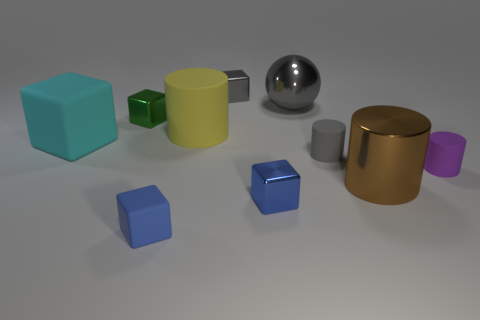There is a tiny object that is the same color as the small rubber cube; what is its material?
Your response must be concise. Metal. There is a brown cylinder that is on the right side of the big matte object that is to the left of the yellow object; are there any tiny objects that are to the right of it?
Ensure brevity in your answer.  Yes. How many objects are either tiny blocks behind the metallic ball or metallic objects that are on the right side of the tiny matte block?
Give a very brief answer. 4. Is the material of the cylinder behind the big cyan thing the same as the tiny purple thing?
Keep it short and to the point. Yes. There is a big thing that is to the right of the big matte cylinder and in front of the yellow matte object; what is it made of?
Offer a very short reply. Metal. What is the color of the matte thing that is on the left side of the matte cube that is in front of the purple matte thing?
Provide a succinct answer. Cyan. There is a brown object that is the same shape as the big yellow object; what material is it?
Give a very brief answer. Metal. The big matte thing that is on the right side of the large matte thing in front of the big cylinder behind the small purple matte cylinder is what color?
Your answer should be very brief. Yellow. What number of objects are tiny purple rubber things or green shiny spheres?
Offer a very short reply. 1. How many big gray things have the same shape as the brown metal thing?
Give a very brief answer. 0. 